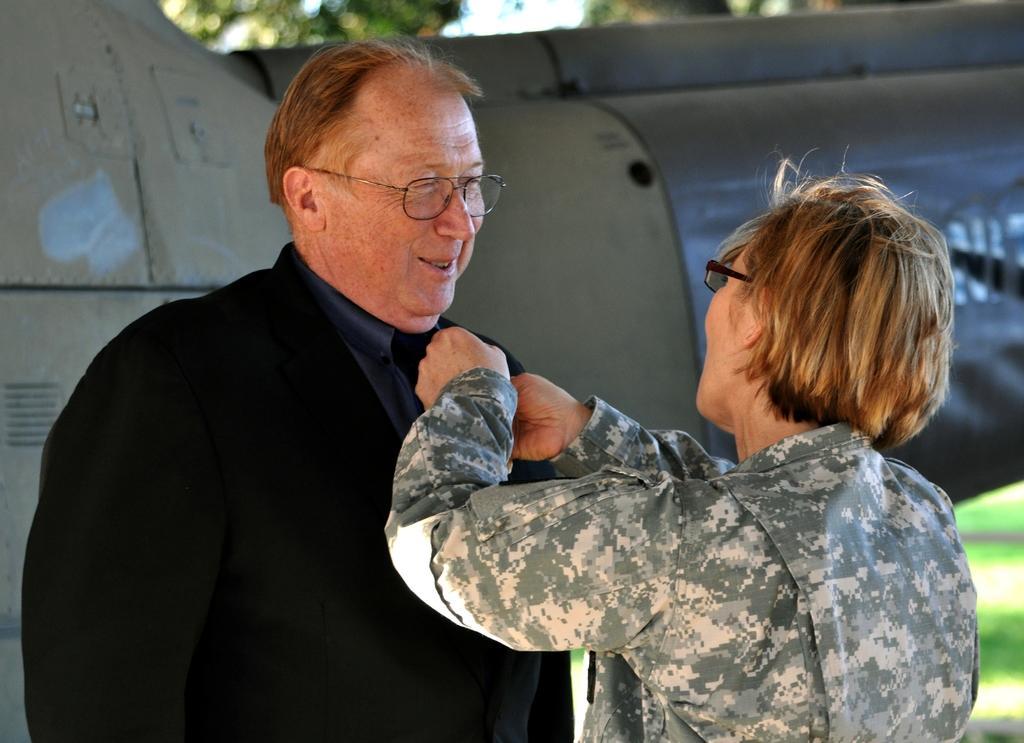Describe this image in one or two sentences. In this image we can see two persons wearing spectacles. One woman is wearing a military uniform. In the background, we can see a vehicle parked on the ground, groups of trees and the sky. 